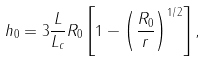Convert formula to latex. <formula><loc_0><loc_0><loc_500><loc_500>h _ { 0 } = 3 \frac { L } { L _ { c } } R _ { 0 } \left [ 1 - \left ( \frac { R _ { 0 } } { r } \right ) ^ { 1 / 2 } \right ] ,</formula> 